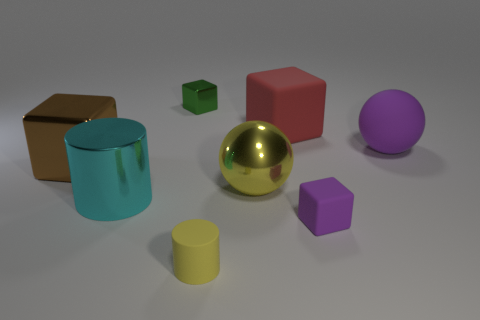There is a small thing on the right side of the small matte object to the left of the large rubber cube; what color is it?
Offer a terse response. Purple. How many other objects are there of the same material as the cyan cylinder?
Make the answer very short. 3. How many metal things are either large green cubes or big cyan cylinders?
Make the answer very short. 1. What is the color of the big rubber object that is the same shape as the yellow shiny thing?
Ensure brevity in your answer.  Purple. What number of things are either yellow matte objects or big red matte balls?
Offer a very short reply. 1. What is the shape of the large thing that is made of the same material as the big purple ball?
Your response must be concise. Cube. How many tiny things are red matte objects or purple rubber objects?
Make the answer very short. 1. What number of other things are the same color as the shiny ball?
Keep it short and to the point. 1. There is a big ball that is behind the shiny cube on the left side of the large cyan metallic cylinder; how many purple rubber objects are in front of it?
Ensure brevity in your answer.  1. Does the rubber cube that is in front of the cyan shiny thing have the same size as the red matte object?
Your answer should be very brief. No. 